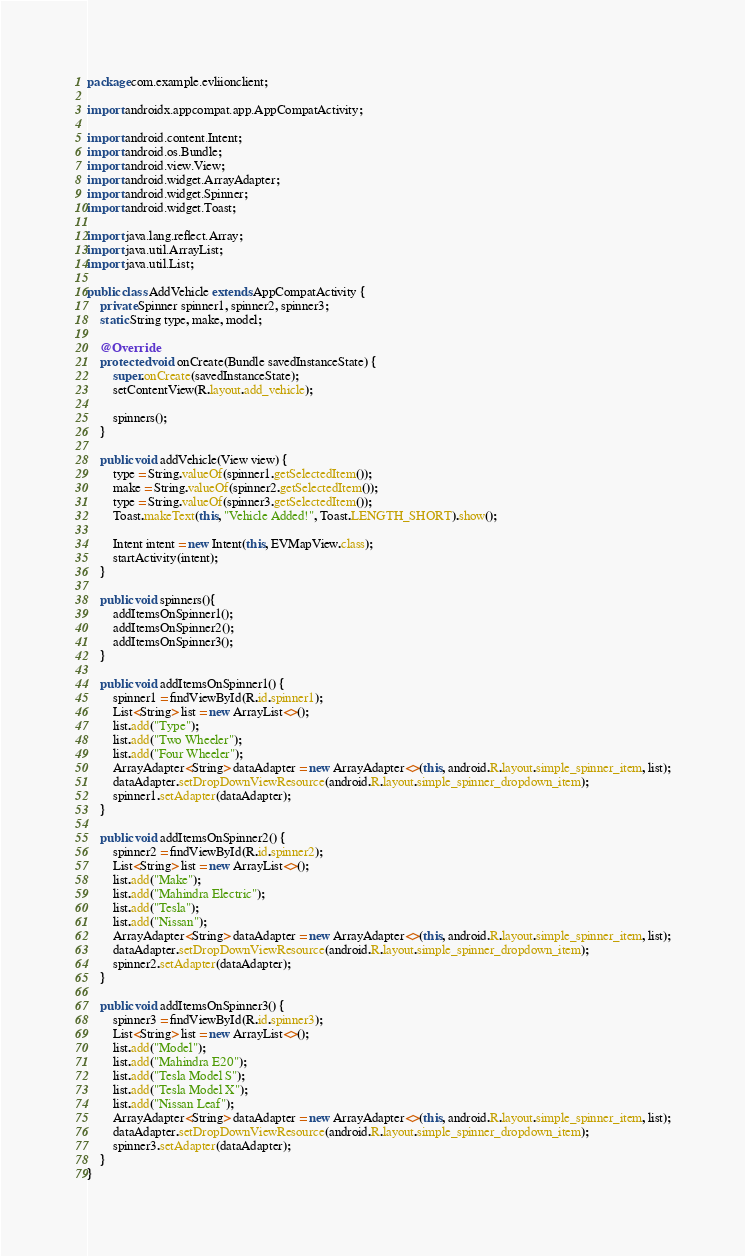<code> <loc_0><loc_0><loc_500><loc_500><_Java_>package com.example.evliionclient;

import androidx.appcompat.app.AppCompatActivity;

import android.content.Intent;
import android.os.Bundle;
import android.view.View;
import android.widget.ArrayAdapter;
import android.widget.Spinner;
import android.widget.Toast;

import java.lang.reflect.Array;
import java.util.ArrayList;
import java.util.List;

public class AddVehicle extends AppCompatActivity {
    private Spinner spinner1, spinner2, spinner3;
    static String type, make, model;

    @Override
    protected void onCreate(Bundle savedInstanceState) {
        super.onCreate(savedInstanceState);
        setContentView(R.layout.add_vehicle);

        spinners();
    }

    public void addVehicle(View view) {
        type = String.valueOf(spinner1.getSelectedItem());
        make = String.valueOf(spinner2.getSelectedItem());
        type = String.valueOf(spinner3.getSelectedItem());
        Toast.makeText(this, "Vehicle Added!", Toast.LENGTH_SHORT).show();

        Intent intent = new Intent(this, EVMapView.class);
        startActivity(intent);
    }

    public void spinners(){
        addItemsOnSpinner1();
        addItemsOnSpinner2();
        addItemsOnSpinner3();
    }

    public void addItemsOnSpinner1() {
        spinner1 = findViewById(R.id.spinner1);
        List<String> list = new ArrayList<>();
        list.add("Type");
        list.add("Two Wheeler");
        list.add("Four Wheeler");
        ArrayAdapter<String> dataAdapter = new ArrayAdapter<>(this, android.R.layout.simple_spinner_item, list);
        dataAdapter.setDropDownViewResource(android.R.layout.simple_spinner_dropdown_item);
        spinner1.setAdapter(dataAdapter);
    }

    public void addItemsOnSpinner2() {
        spinner2 = findViewById(R.id.spinner2);
        List<String> list = new ArrayList<>();
        list.add("Make");
        list.add("Mahindra Electric");
        list.add("Tesla");
        list.add("Nissan");
        ArrayAdapter<String> dataAdapter = new ArrayAdapter<>(this, android.R.layout.simple_spinner_item, list);
        dataAdapter.setDropDownViewResource(android.R.layout.simple_spinner_dropdown_item);
        spinner2.setAdapter(dataAdapter);
    }

    public void addItemsOnSpinner3() {
        spinner3 = findViewById(R.id.spinner3);
        List<String> list = new ArrayList<>();
        list.add("Model");
        list.add("Mahindra E20");
        list.add("Tesla Model S");
        list.add("Tesla Model X");
        list.add("Nissan Leaf");
        ArrayAdapter<String> dataAdapter = new ArrayAdapter<>(this, android.R.layout.simple_spinner_item, list);
        dataAdapter.setDropDownViewResource(android.R.layout.simple_spinner_dropdown_item);
        spinner3.setAdapter(dataAdapter);
    }
}
</code> 